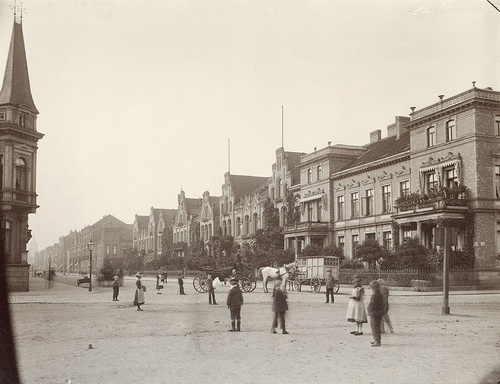Describe the objects in this image and their specific colors. I can see people in lightgray, gray, black, and darkgray tones, people in lightgray, darkgray, and gray tones, people in lightgray, gray, black, and darkgray tones, horse in lightgray, darkgray, and gray tones, and people in lightgray, gray, black, and darkgray tones in this image. 